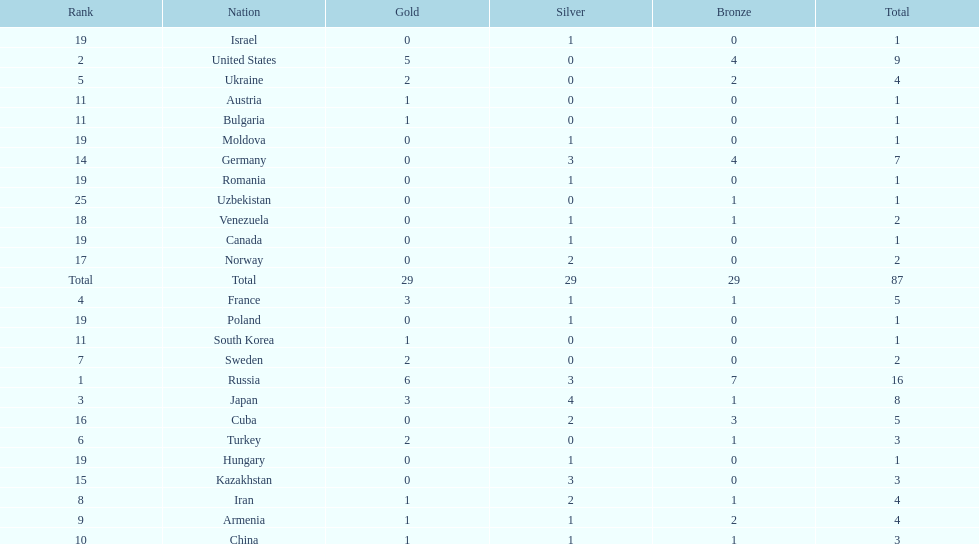Which country won only one medal, a bronze medal? Uzbekistan. 